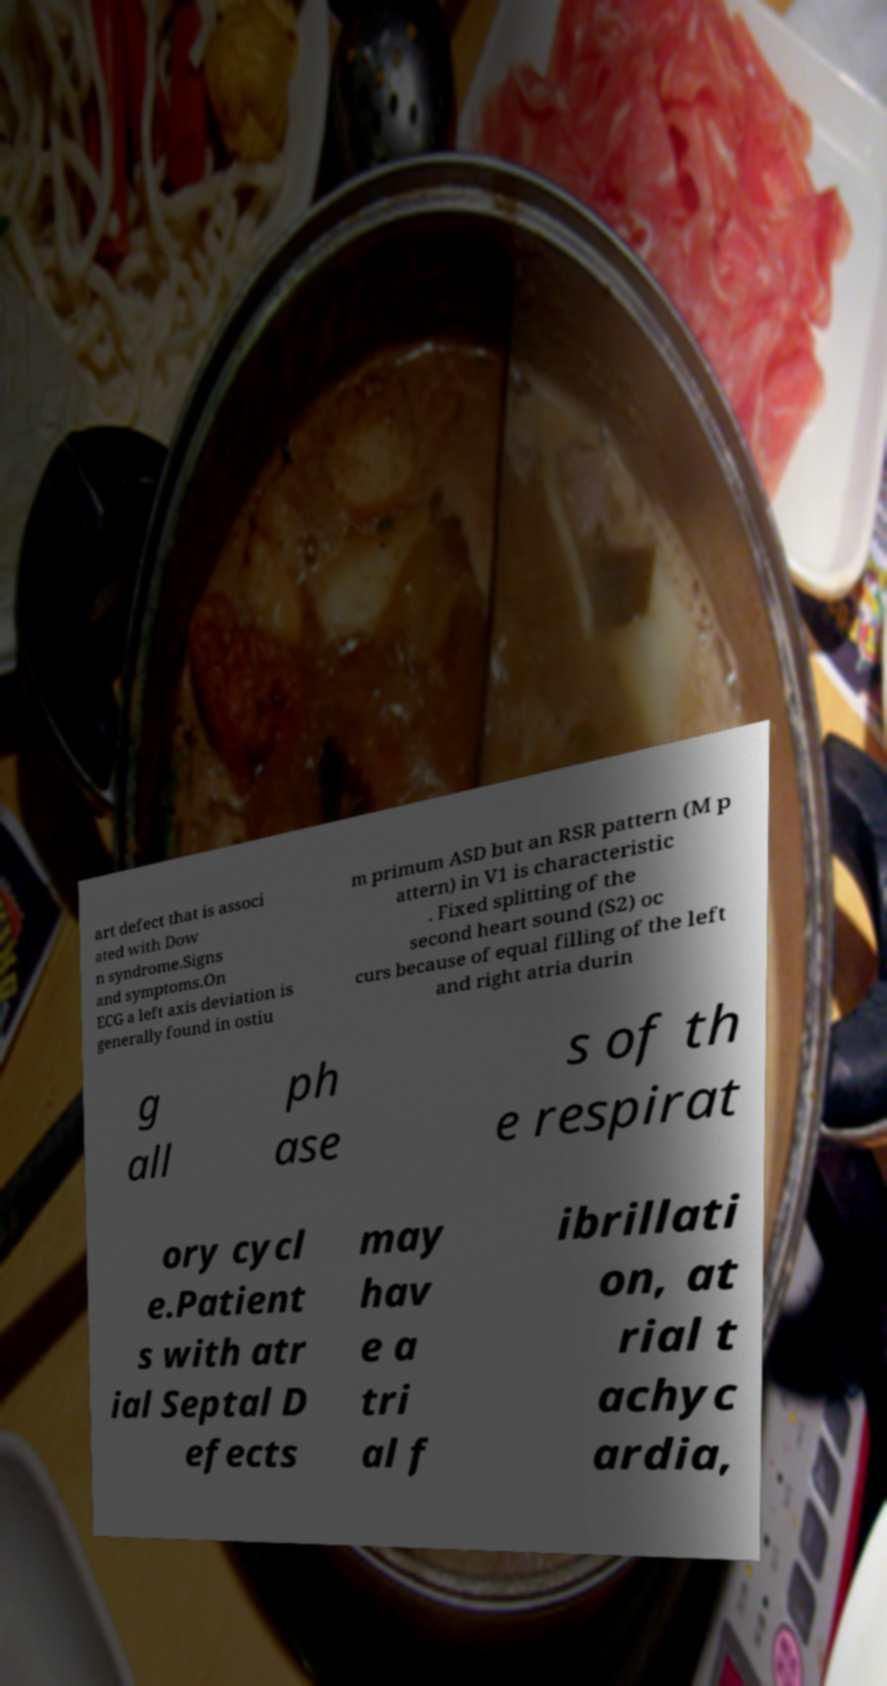Can you accurately transcribe the text from the provided image for me? art defect that is associ ated with Dow n syndrome.Signs and symptoms.On ECG a left axis deviation is generally found in ostiu m primum ASD but an RSR pattern (M p attern) in V1 is characteristic . Fixed splitting of the second heart sound (S2) oc curs because of equal filling of the left and right atria durin g all ph ase s of th e respirat ory cycl e.Patient s with atr ial Septal D efects may hav e a tri al f ibrillati on, at rial t achyc ardia, 